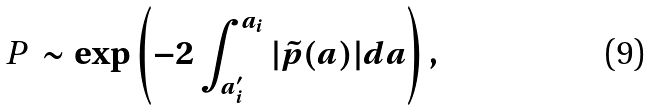Convert formula to latex. <formula><loc_0><loc_0><loc_500><loc_500>\emph { P } \sim \exp \left ( - 2 \int _ { a ^ { \prime } _ { i } } ^ { a _ { i } } { | { \tilde { p } ( a ) } | } d a \right ) ,</formula> 